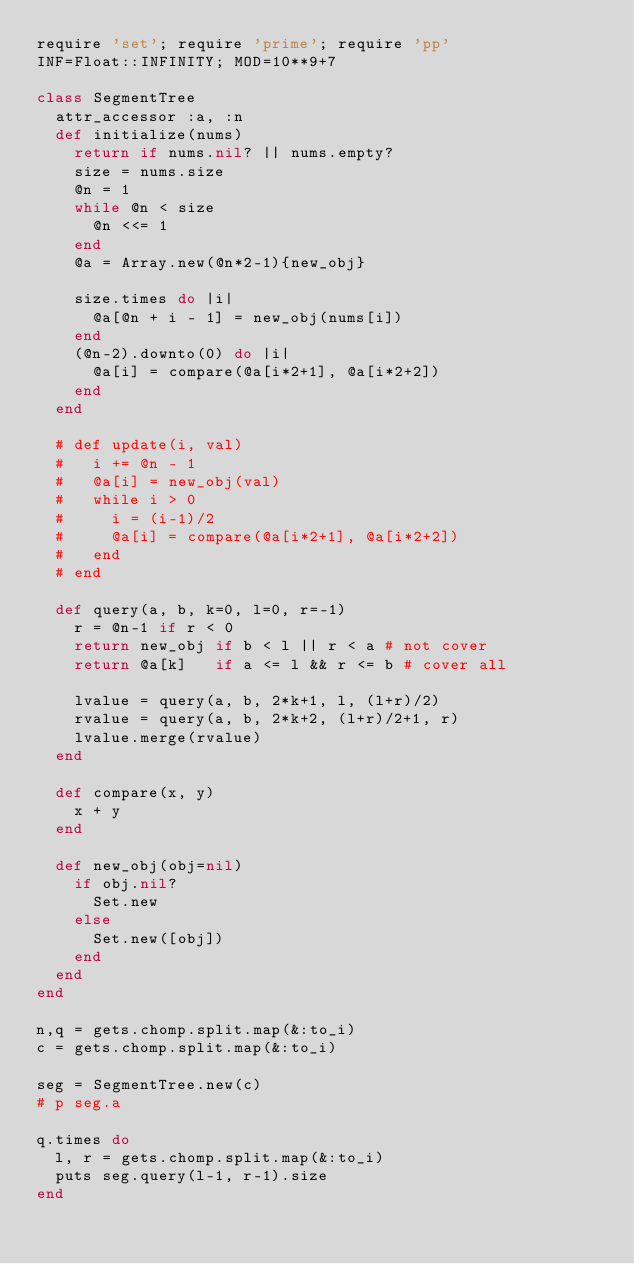<code> <loc_0><loc_0><loc_500><loc_500><_Ruby_>require 'set'; require 'prime'; require 'pp'
INF=Float::INFINITY; MOD=10**9+7

class SegmentTree
  attr_accessor :a, :n
  def initialize(nums)
    return if nums.nil? || nums.empty?
    size = nums.size
    @n = 1
    while @n < size
      @n <<= 1
    end
    @a = Array.new(@n*2-1){new_obj}

    size.times do |i|
      @a[@n + i - 1] = new_obj(nums[i])
    end
    (@n-2).downto(0) do |i|
      @a[i] = compare(@a[i*2+1], @a[i*2+2])
    end
  end

  # def update(i, val)
  #   i += @n - 1
  #   @a[i] = new_obj(val)
  #   while i > 0
  #     i = (i-1)/2
  #     @a[i] = compare(@a[i*2+1], @a[i*2+2])
  #   end
  # end

  def query(a, b, k=0, l=0, r=-1)
    r = @n-1 if r < 0
    return new_obj if b < l || r < a # not cover
    return @a[k]   if a <= l && r <= b # cover all

    lvalue = query(a, b, 2*k+1, l, (l+r)/2)
    rvalue = query(a, b, 2*k+2, (l+r)/2+1, r)
    lvalue.merge(rvalue)
  end

  def compare(x, y)
    x + y
  end

  def new_obj(obj=nil)
    if obj.nil?
      Set.new
    else
      Set.new([obj])
    end
  end
end

n,q = gets.chomp.split.map(&:to_i)
c = gets.chomp.split.map(&:to_i)

seg = SegmentTree.new(c)
# p seg.a

q.times do
  l, r = gets.chomp.split.map(&:to_i)
  puts seg.query(l-1, r-1).size
end
</code> 